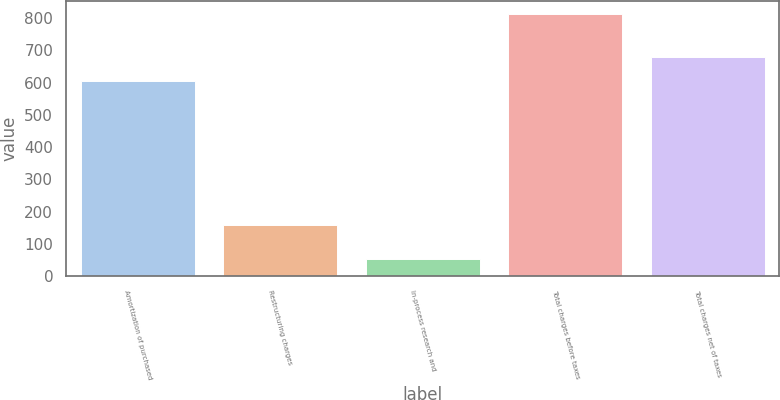Convert chart to OTSL. <chart><loc_0><loc_0><loc_500><loc_500><bar_chart><fcel>Amortization of purchased<fcel>Restructuring charges<fcel>In-process research and<fcel>Total charges before taxes<fcel>Total charges net of taxes<nl><fcel>604<fcel>158<fcel>52<fcel>814<fcel>680.2<nl></chart> 